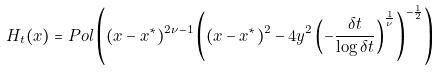<formula> <loc_0><loc_0><loc_500><loc_500>H _ { t } ( x ) = P o l \left ( ( x - x ^ { \ast } ) ^ { 2 \nu - 1 } \left ( ( x - x ^ { \ast } ) ^ { 2 } - 4 y ^ { 2 } \left ( - \frac { \delta t } { \log \delta t } \right ) ^ { \frac { 1 } { \nu } } \right ) ^ { - \frac { 1 } { 2 } } \right )</formula> 